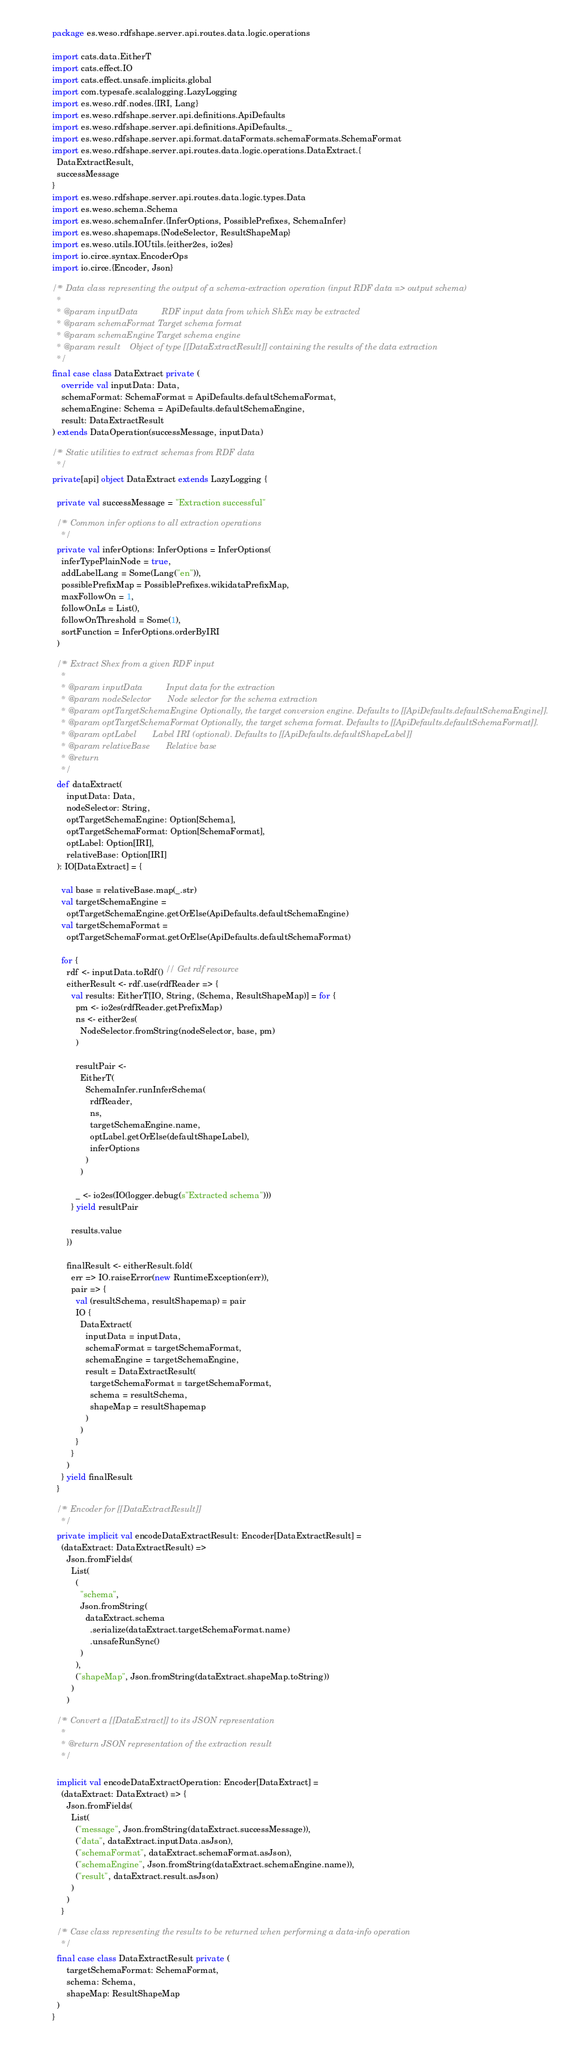Convert code to text. <code><loc_0><loc_0><loc_500><loc_500><_Scala_>package es.weso.rdfshape.server.api.routes.data.logic.operations

import cats.data.EitherT
import cats.effect.IO
import cats.effect.unsafe.implicits.global
import com.typesafe.scalalogging.LazyLogging
import es.weso.rdf.nodes.{IRI, Lang}
import es.weso.rdfshape.server.api.definitions.ApiDefaults
import es.weso.rdfshape.server.api.definitions.ApiDefaults._
import es.weso.rdfshape.server.api.format.dataFormats.schemaFormats.SchemaFormat
import es.weso.rdfshape.server.api.routes.data.logic.operations.DataExtract.{
  DataExtractResult,
  successMessage
}
import es.weso.rdfshape.server.api.routes.data.logic.types.Data
import es.weso.schema.Schema
import es.weso.schemaInfer.{InferOptions, PossiblePrefixes, SchemaInfer}
import es.weso.shapemaps.{NodeSelector, ResultShapeMap}
import es.weso.utils.IOUtils.{either2es, io2es}
import io.circe.syntax.EncoderOps
import io.circe.{Encoder, Json}

/** Data class representing the output of a schema-extraction operation (input RDF data => output schema)
  *
  * @param inputData          RDF input data from which ShEx may be extracted
  * @param schemaFormat Target schema format
  * @param schemaEngine Target schema engine
  * @param result    Object of type [[DataExtractResult]] containing the results of the data extraction
  */
final case class DataExtract private (
    override val inputData: Data,
    schemaFormat: SchemaFormat = ApiDefaults.defaultSchemaFormat,
    schemaEngine: Schema = ApiDefaults.defaultSchemaEngine,
    result: DataExtractResult
) extends DataOperation(successMessage, inputData)

/** Static utilities to extract schemas from RDF data
  */
private[api] object DataExtract extends LazyLogging {

  private val successMessage = "Extraction successful"

  /** Common infer options to all extraction operations
    */
  private val inferOptions: InferOptions = InferOptions(
    inferTypePlainNode = true,
    addLabelLang = Some(Lang("en")),
    possiblePrefixMap = PossiblePrefixes.wikidataPrefixMap,
    maxFollowOn = 1,
    followOnLs = List(),
    followOnThreshold = Some(1),
    sortFunction = InferOptions.orderByIRI
  )

  /** Extract Shex from a given RDF input
    *
    * @param inputData          Input data for the extraction
    * @param nodeSelector       Node selector for the schema extraction
    * @param optTargetSchemaEngine Optionally, the target conversion engine. Defaults to [[ApiDefaults.defaultSchemaEngine]].
    * @param optTargetSchemaFormat Optionally, the target schema format. Defaults to [[ApiDefaults.defaultSchemaFormat]].
    * @param optLabel       Label IRI (optional). Defaults to [[ApiDefaults.defaultShapeLabel]]
    * @param relativeBase       Relative base
    * @return
    */
  def dataExtract(
      inputData: Data,
      nodeSelector: String,
      optTargetSchemaEngine: Option[Schema],
      optTargetSchemaFormat: Option[SchemaFormat],
      optLabel: Option[IRI],
      relativeBase: Option[IRI]
  ): IO[DataExtract] = {

    val base = relativeBase.map(_.str)
    val targetSchemaEngine =
      optTargetSchemaEngine.getOrElse(ApiDefaults.defaultSchemaEngine)
    val targetSchemaFormat =
      optTargetSchemaFormat.getOrElse(ApiDefaults.defaultSchemaFormat)

    for {
      rdf <- inputData.toRdf() // Get rdf resource
      eitherResult <- rdf.use(rdfReader => {
        val results: EitherT[IO, String, (Schema, ResultShapeMap)] = for {
          pm <- io2es(rdfReader.getPrefixMap)
          ns <- either2es(
            NodeSelector.fromString(nodeSelector, base, pm)
          )

          resultPair <-
            EitherT(
              SchemaInfer.runInferSchema(
                rdfReader,
                ns,
                targetSchemaEngine.name,
                optLabel.getOrElse(defaultShapeLabel),
                inferOptions
              )
            )

          _ <- io2es(IO(logger.debug(s"Extracted schema")))
        } yield resultPair

        results.value
      })

      finalResult <- eitherResult.fold(
        err => IO.raiseError(new RuntimeException(err)),
        pair => {
          val (resultSchema, resultShapemap) = pair
          IO {
            DataExtract(
              inputData = inputData,
              schemaFormat = targetSchemaFormat,
              schemaEngine = targetSchemaEngine,
              result = DataExtractResult(
                targetSchemaFormat = targetSchemaFormat,
                schema = resultSchema,
                shapeMap = resultShapemap
              )
            )
          }
        }
      )
    } yield finalResult
  }

  /** Encoder for [[DataExtractResult]]
    */
  private implicit val encodeDataExtractResult: Encoder[DataExtractResult] =
    (dataExtract: DataExtractResult) =>
      Json.fromFields(
        List(
          (
            "schema",
            Json.fromString(
              dataExtract.schema
                .serialize(dataExtract.targetSchemaFormat.name)
                .unsafeRunSync()
            )
          ),
          ("shapeMap", Json.fromString(dataExtract.shapeMap.toString))
        )
      )

  /** Convert a [[DataExtract]] to its JSON representation
    *
    * @return JSON representation of the extraction result
    */

  implicit val encodeDataExtractOperation: Encoder[DataExtract] =
    (dataExtract: DataExtract) => {
      Json.fromFields(
        List(
          ("message", Json.fromString(dataExtract.successMessage)),
          ("data", dataExtract.inputData.asJson),
          ("schemaFormat", dataExtract.schemaFormat.asJson),
          ("schemaEngine", Json.fromString(dataExtract.schemaEngine.name)),
          ("result", dataExtract.result.asJson)
        )
      )
    }

  /** Case class representing the results to be returned when performing a data-info operation
    */
  final case class DataExtractResult private (
      targetSchemaFormat: SchemaFormat,
      schema: Schema,
      shapeMap: ResultShapeMap
  )
}
</code> 